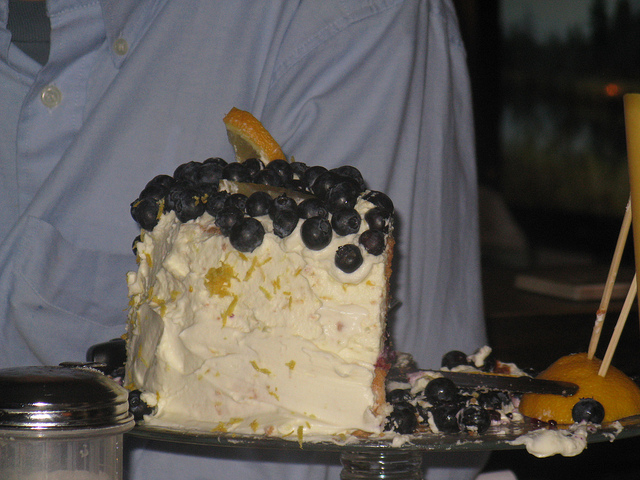<image>What are the popsicle sticks used for? I don't know what the popsicle sticks are used for. They could be used for decoration or for eating. What are the popsicle sticks used for? I don't know what the popsicle sticks are used for. It can be for decoration, holding orange slices, or eating. 